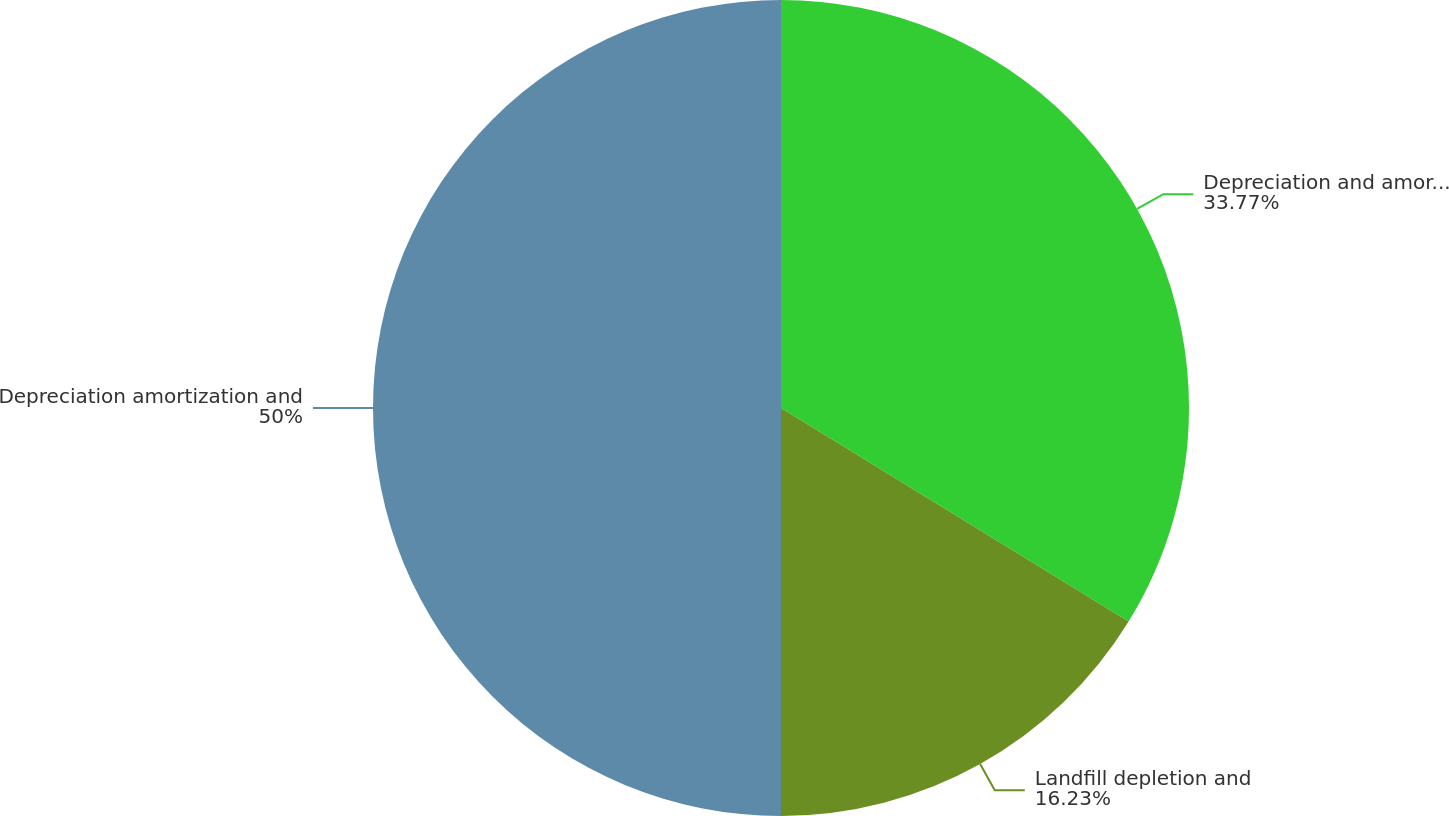Convert chart. <chart><loc_0><loc_0><loc_500><loc_500><pie_chart><fcel>Depreciation and amortization<fcel>Landfill depletion and<fcel>Depreciation amortization and<nl><fcel>33.77%<fcel>16.23%<fcel>50.0%<nl></chart> 